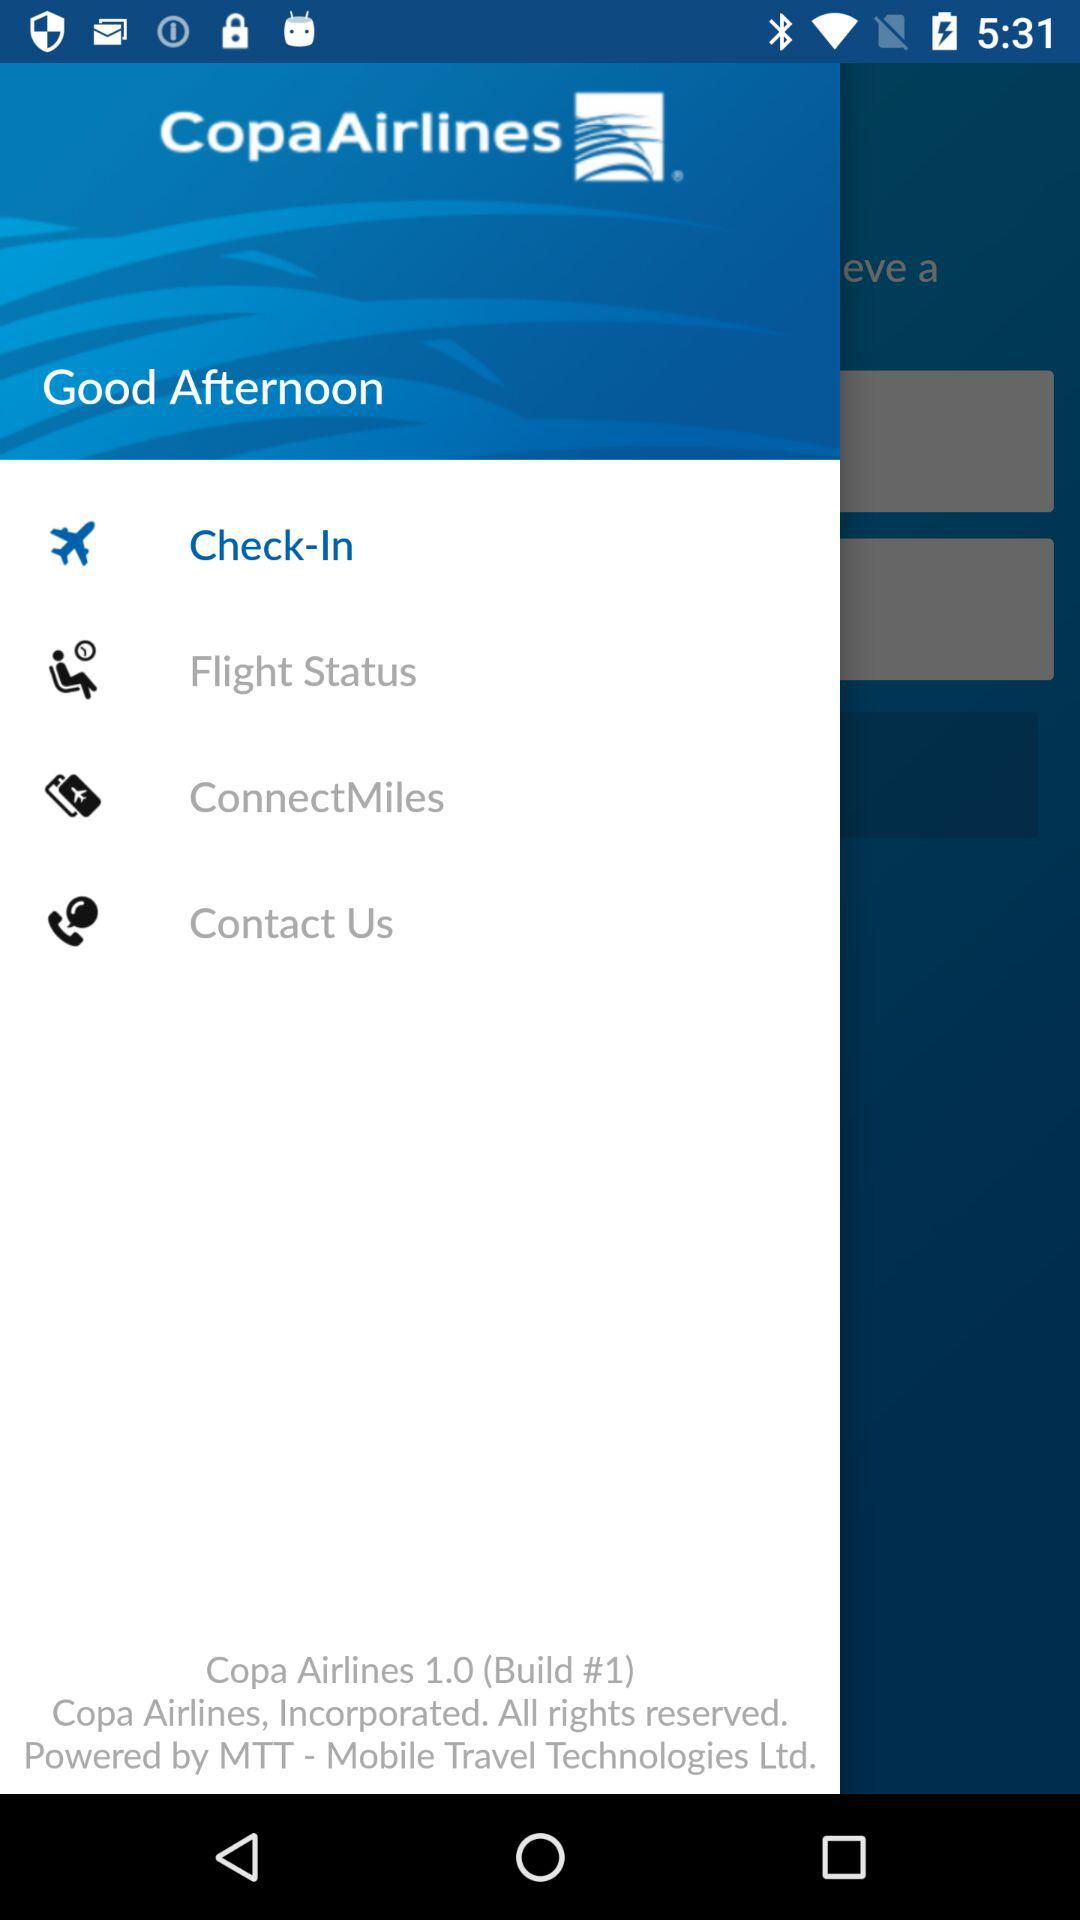What is the version of the app? The version of the app is 1.0 (Build #1). 